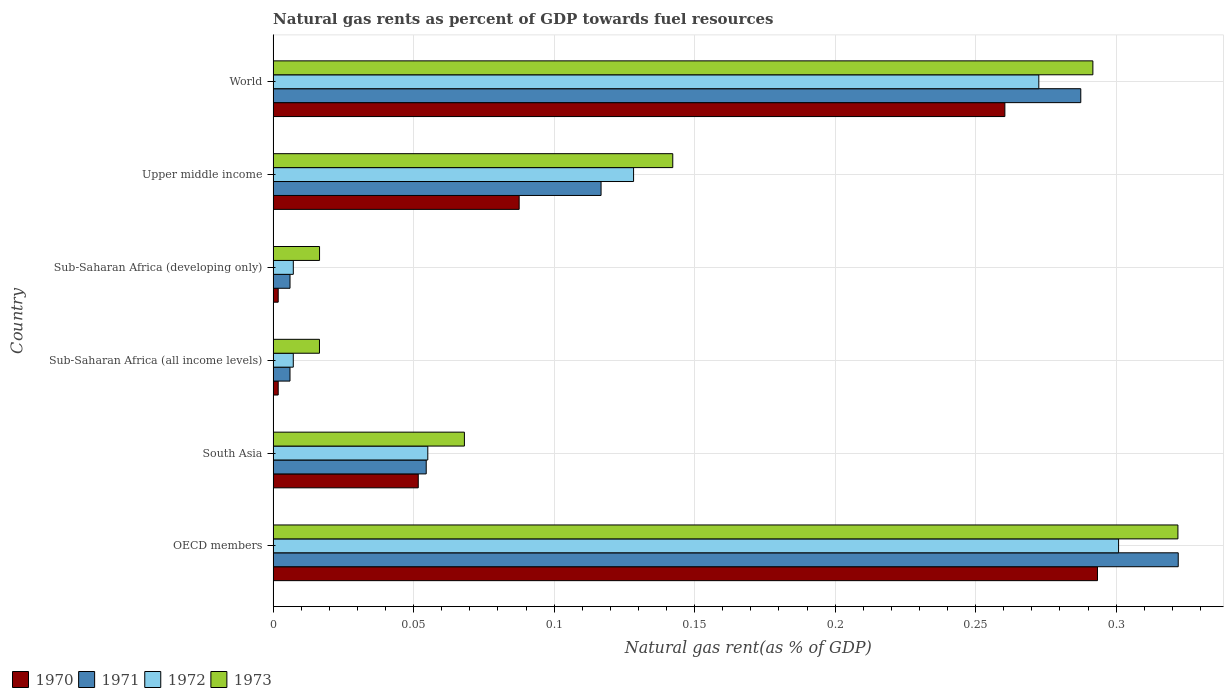Are the number of bars per tick equal to the number of legend labels?
Your answer should be very brief. Yes. How many bars are there on the 5th tick from the bottom?
Your response must be concise. 4. What is the label of the 2nd group of bars from the top?
Offer a very short reply. Upper middle income. In how many cases, is the number of bars for a given country not equal to the number of legend labels?
Your answer should be very brief. 0. What is the natural gas rent in 1970 in OECD members?
Provide a short and direct response. 0.29. Across all countries, what is the maximum natural gas rent in 1973?
Make the answer very short. 0.32. Across all countries, what is the minimum natural gas rent in 1971?
Ensure brevity in your answer.  0.01. In which country was the natural gas rent in 1972 minimum?
Your answer should be very brief. Sub-Saharan Africa (all income levels). What is the total natural gas rent in 1973 in the graph?
Offer a terse response. 0.86. What is the difference between the natural gas rent in 1972 in Upper middle income and that in World?
Provide a short and direct response. -0.14. What is the difference between the natural gas rent in 1972 in OECD members and the natural gas rent in 1973 in Upper middle income?
Keep it short and to the point. 0.16. What is the average natural gas rent in 1973 per country?
Provide a succinct answer. 0.14. What is the difference between the natural gas rent in 1970 and natural gas rent in 1973 in OECD members?
Your response must be concise. -0.03. In how many countries, is the natural gas rent in 1971 greater than 0.05 %?
Your response must be concise. 4. What is the ratio of the natural gas rent in 1971 in Sub-Saharan Africa (developing only) to that in World?
Make the answer very short. 0.02. What is the difference between the highest and the second highest natural gas rent in 1971?
Your answer should be very brief. 0.03. What is the difference between the highest and the lowest natural gas rent in 1970?
Your response must be concise. 0.29. In how many countries, is the natural gas rent in 1971 greater than the average natural gas rent in 1971 taken over all countries?
Offer a very short reply. 2. Is it the case that in every country, the sum of the natural gas rent in 1970 and natural gas rent in 1972 is greater than the sum of natural gas rent in 1971 and natural gas rent in 1973?
Provide a short and direct response. No. Is it the case that in every country, the sum of the natural gas rent in 1972 and natural gas rent in 1973 is greater than the natural gas rent in 1970?
Make the answer very short. Yes. How many countries are there in the graph?
Offer a terse response. 6. Does the graph contain grids?
Give a very brief answer. Yes. What is the title of the graph?
Your response must be concise. Natural gas rents as percent of GDP towards fuel resources. Does "1970" appear as one of the legend labels in the graph?
Offer a very short reply. Yes. What is the label or title of the X-axis?
Your answer should be compact. Natural gas rent(as % of GDP). What is the label or title of the Y-axis?
Keep it short and to the point. Country. What is the Natural gas rent(as % of GDP) of 1970 in OECD members?
Provide a short and direct response. 0.29. What is the Natural gas rent(as % of GDP) of 1971 in OECD members?
Make the answer very short. 0.32. What is the Natural gas rent(as % of GDP) of 1972 in OECD members?
Offer a very short reply. 0.3. What is the Natural gas rent(as % of GDP) of 1973 in OECD members?
Your response must be concise. 0.32. What is the Natural gas rent(as % of GDP) in 1970 in South Asia?
Make the answer very short. 0.05. What is the Natural gas rent(as % of GDP) of 1971 in South Asia?
Give a very brief answer. 0.05. What is the Natural gas rent(as % of GDP) of 1972 in South Asia?
Ensure brevity in your answer.  0.06. What is the Natural gas rent(as % of GDP) in 1973 in South Asia?
Your response must be concise. 0.07. What is the Natural gas rent(as % of GDP) of 1970 in Sub-Saharan Africa (all income levels)?
Offer a terse response. 0. What is the Natural gas rent(as % of GDP) of 1971 in Sub-Saharan Africa (all income levels)?
Your response must be concise. 0.01. What is the Natural gas rent(as % of GDP) of 1972 in Sub-Saharan Africa (all income levels)?
Offer a terse response. 0.01. What is the Natural gas rent(as % of GDP) in 1973 in Sub-Saharan Africa (all income levels)?
Provide a succinct answer. 0.02. What is the Natural gas rent(as % of GDP) of 1970 in Sub-Saharan Africa (developing only)?
Keep it short and to the point. 0. What is the Natural gas rent(as % of GDP) in 1971 in Sub-Saharan Africa (developing only)?
Make the answer very short. 0.01. What is the Natural gas rent(as % of GDP) in 1972 in Sub-Saharan Africa (developing only)?
Offer a terse response. 0.01. What is the Natural gas rent(as % of GDP) in 1973 in Sub-Saharan Africa (developing only)?
Keep it short and to the point. 0.02. What is the Natural gas rent(as % of GDP) in 1970 in Upper middle income?
Your answer should be compact. 0.09. What is the Natural gas rent(as % of GDP) in 1971 in Upper middle income?
Your response must be concise. 0.12. What is the Natural gas rent(as % of GDP) of 1972 in Upper middle income?
Offer a very short reply. 0.13. What is the Natural gas rent(as % of GDP) of 1973 in Upper middle income?
Provide a succinct answer. 0.14. What is the Natural gas rent(as % of GDP) of 1970 in World?
Provide a succinct answer. 0.26. What is the Natural gas rent(as % of GDP) in 1971 in World?
Your answer should be very brief. 0.29. What is the Natural gas rent(as % of GDP) of 1972 in World?
Make the answer very short. 0.27. What is the Natural gas rent(as % of GDP) of 1973 in World?
Make the answer very short. 0.29. Across all countries, what is the maximum Natural gas rent(as % of GDP) in 1970?
Keep it short and to the point. 0.29. Across all countries, what is the maximum Natural gas rent(as % of GDP) of 1971?
Make the answer very short. 0.32. Across all countries, what is the maximum Natural gas rent(as % of GDP) in 1972?
Ensure brevity in your answer.  0.3. Across all countries, what is the maximum Natural gas rent(as % of GDP) in 1973?
Provide a succinct answer. 0.32. Across all countries, what is the minimum Natural gas rent(as % of GDP) of 1970?
Provide a short and direct response. 0. Across all countries, what is the minimum Natural gas rent(as % of GDP) of 1971?
Make the answer very short. 0.01. Across all countries, what is the minimum Natural gas rent(as % of GDP) in 1972?
Give a very brief answer. 0.01. Across all countries, what is the minimum Natural gas rent(as % of GDP) of 1973?
Your response must be concise. 0.02. What is the total Natural gas rent(as % of GDP) of 1970 in the graph?
Give a very brief answer. 0.7. What is the total Natural gas rent(as % of GDP) in 1971 in the graph?
Offer a very short reply. 0.79. What is the total Natural gas rent(as % of GDP) in 1972 in the graph?
Your answer should be very brief. 0.77. What is the total Natural gas rent(as % of GDP) in 1973 in the graph?
Offer a very short reply. 0.86. What is the difference between the Natural gas rent(as % of GDP) of 1970 in OECD members and that in South Asia?
Offer a terse response. 0.24. What is the difference between the Natural gas rent(as % of GDP) in 1971 in OECD members and that in South Asia?
Offer a terse response. 0.27. What is the difference between the Natural gas rent(as % of GDP) of 1972 in OECD members and that in South Asia?
Keep it short and to the point. 0.25. What is the difference between the Natural gas rent(as % of GDP) in 1973 in OECD members and that in South Asia?
Ensure brevity in your answer.  0.25. What is the difference between the Natural gas rent(as % of GDP) in 1970 in OECD members and that in Sub-Saharan Africa (all income levels)?
Keep it short and to the point. 0.29. What is the difference between the Natural gas rent(as % of GDP) in 1971 in OECD members and that in Sub-Saharan Africa (all income levels)?
Give a very brief answer. 0.32. What is the difference between the Natural gas rent(as % of GDP) in 1972 in OECD members and that in Sub-Saharan Africa (all income levels)?
Provide a short and direct response. 0.29. What is the difference between the Natural gas rent(as % of GDP) in 1973 in OECD members and that in Sub-Saharan Africa (all income levels)?
Give a very brief answer. 0.31. What is the difference between the Natural gas rent(as % of GDP) of 1970 in OECD members and that in Sub-Saharan Africa (developing only)?
Give a very brief answer. 0.29. What is the difference between the Natural gas rent(as % of GDP) in 1971 in OECD members and that in Sub-Saharan Africa (developing only)?
Your answer should be compact. 0.32. What is the difference between the Natural gas rent(as % of GDP) of 1972 in OECD members and that in Sub-Saharan Africa (developing only)?
Your response must be concise. 0.29. What is the difference between the Natural gas rent(as % of GDP) of 1973 in OECD members and that in Sub-Saharan Africa (developing only)?
Ensure brevity in your answer.  0.31. What is the difference between the Natural gas rent(as % of GDP) in 1970 in OECD members and that in Upper middle income?
Offer a very short reply. 0.21. What is the difference between the Natural gas rent(as % of GDP) of 1971 in OECD members and that in Upper middle income?
Give a very brief answer. 0.21. What is the difference between the Natural gas rent(as % of GDP) of 1972 in OECD members and that in Upper middle income?
Offer a terse response. 0.17. What is the difference between the Natural gas rent(as % of GDP) in 1973 in OECD members and that in Upper middle income?
Ensure brevity in your answer.  0.18. What is the difference between the Natural gas rent(as % of GDP) in 1970 in OECD members and that in World?
Keep it short and to the point. 0.03. What is the difference between the Natural gas rent(as % of GDP) of 1971 in OECD members and that in World?
Ensure brevity in your answer.  0.03. What is the difference between the Natural gas rent(as % of GDP) in 1972 in OECD members and that in World?
Offer a very short reply. 0.03. What is the difference between the Natural gas rent(as % of GDP) of 1973 in OECD members and that in World?
Provide a succinct answer. 0.03. What is the difference between the Natural gas rent(as % of GDP) of 1970 in South Asia and that in Sub-Saharan Africa (all income levels)?
Provide a succinct answer. 0.05. What is the difference between the Natural gas rent(as % of GDP) of 1971 in South Asia and that in Sub-Saharan Africa (all income levels)?
Your response must be concise. 0.05. What is the difference between the Natural gas rent(as % of GDP) of 1972 in South Asia and that in Sub-Saharan Africa (all income levels)?
Offer a terse response. 0.05. What is the difference between the Natural gas rent(as % of GDP) in 1973 in South Asia and that in Sub-Saharan Africa (all income levels)?
Give a very brief answer. 0.05. What is the difference between the Natural gas rent(as % of GDP) in 1970 in South Asia and that in Sub-Saharan Africa (developing only)?
Your answer should be very brief. 0.05. What is the difference between the Natural gas rent(as % of GDP) of 1971 in South Asia and that in Sub-Saharan Africa (developing only)?
Keep it short and to the point. 0.05. What is the difference between the Natural gas rent(as % of GDP) of 1972 in South Asia and that in Sub-Saharan Africa (developing only)?
Offer a terse response. 0.05. What is the difference between the Natural gas rent(as % of GDP) in 1973 in South Asia and that in Sub-Saharan Africa (developing only)?
Keep it short and to the point. 0.05. What is the difference between the Natural gas rent(as % of GDP) of 1970 in South Asia and that in Upper middle income?
Keep it short and to the point. -0.04. What is the difference between the Natural gas rent(as % of GDP) of 1971 in South Asia and that in Upper middle income?
Keep it short and to the point. -0.06. What is the difference between the Natural gas rent(as % of GDP) in 1972 in South Asia and that in Upper middle income?
Provide a short and direct response. -0.07. What is the difference between the Natural gas rent(as % of GDP) of 1973 in South Asia and that in Upper middle income?
Give a very brief answer. -0.07. What is the difference between the Natural gas rent(as % of GDP) in 1970 in South Asia and that in World?
Provide a succinct answer. -0.21. What is the difference between the Natural gas rent(as % of GDP) in 1971 in South Asia and that in World?
Offer a terse response. -0.23. What is the difference between the Natural gas rent(as % of GDP) in 1972 in South Asia and that in World?
Your response must be concise. -0.22. What is the difference between the Natural gas rent(as % of GDP) of 1973 in South Asia and that in World?
Offer a terse response. -0.22. What is the difference between the Natural gas rent(as % of GDP) in 1970 in Sub-Saharan Africa (all income levels) and that in Sub-Saharan Africa (developing only)?
Your response must be concise. -0. What is the difference between the Natural gas rent(as % of GDP) in 1971 in Sub-Saharan Africa (all income levels) and that in Sub-Saharan Africa (developing only)?
Your response must be concise. -0. What is the difference between the Natural gas rent(as % of GDP) in 1972 in Sub-Saharan Africa (all income levels) and that in Sub-Saharan Africa (developing only)?
Provide a short and direct response. -0. What is the difference between the Natural gas rent(as % of GDP) of 1973 in Sub-Saharan Africa (all income levels) and that in Sub-Saharan Africa (developing only)?
Provide a succinct answer. -0. What is the difference between the Natural gas rent(as % of GDP) in 1970 in Sub-Saharan Africa (all income levels) and that in Upper middle income?
Your response must be concise. -0.09. What is the difference between the Natural gas rent(as % of GDP) in 1971 in Sub-Saharan Africa (all income levels) and that in Upper middle income?
Give a very brief answer. -0.11. What is the difference between the Natural gas rent(as % of GDP) in 1972 in Sub-Saharan Africa (all income levels) and that in Upper middle income?
Provide a succinct answer. -0.12. What is the difference between the Natural gas rent(as % of GDP) of 1973 in Sub-Saharan Africa (all income levels) and that in Upper middle income?
Offer a terse response. -0.13. What is the difference between the Natural gas rent(as % of GDP) in 1970 in Sub-Saharan Africa (all income levels) and that in World?
Your response must be concise. -0.26. What is the difference between the Natural gas rent(as % of GDP) of 1971 in Sub-Saharan Africa (all income levels) and that in World?
Offer a terse response. -0.28. What is the difference between the Natural gas rent(as % of GDP) of 1972 in Sub-Saharan Africa (all income levels) and that in World?
Offer a terse response. -0.27. What is the difference between the Natural gas rent(as % of GDP) in 1973 in Sub-Saharan Africa (all income levels) and that in World?
Give a very brief answer. -0.28. What is the difference between the Natural gas rent(as % of GDP) of 1970 in Sub-Saharan Africa (developing only) and that in Upper middle income?
Make the answer very short. -0.09. What is the difference between the Natural gas rent(as % of GDP) in 1971 in Sub-Saharan Africa (developing only) and that in Upper middle income?
Keep it short and to the point. -0.11. What is the difference between the Natural gas rent(as % of GDP) in 1972 in Sub-Saharan Africa (developing only) and that in Upper middle income?
Ensure brevity in your answer.  -0.12. What is the difference between the Natural gas rent(as % of GDP) in 1973 in Sub-Saharan Africa (developing only) and that in Upper middle income?
Ensure brevity in your answer.  -0.13. What is the difference between the Natural gas rent(as % of GDP) of 1970 in Sub-Saharan Africa (developing only) and that in World?
Keep it short and to the point. -0.26. What is the difference between the Natural gas rent(as % of GDP) of 1971 in Sub-Saharan Africa (developing only) and that in World?
Offer a terse response. -0.28. What is the difference between the Natural gas rent(as % of GDP) in 1972 in Sub-Saharan Africa (developing only) and that in World?
Your answer should be compact. -0.27. What is the difference between the Natural gas rent(as % of GDP) in 1973 in Sub-Saharan Africa (developing only) and that in World?
Make the answer very short. -0.28. What is the difference between the Natural gas rent(as % of GDP) in 1970 in Upper middle income and that in World?
Keep it short and to the point. -0.17. What is the difference between the Natural gas rent(as % of GDP) in 1971 in Upper middle income and that in World?
Offer a terse response. -0.17. What is the difference between the Natural gas rent(as % of GDP) in 1972 in Upper middle income and that in World?
Give a very brief answer. -0.14. What is the difference between the Natural gas rent(as % of GDP) in 1973 in Upper middle income and that in World?
Offer a very short reply. -0.15. What is the difference between the Natural gas rent(as % of GDP) in 1970 in OECD members and the Natural gas rent(as % of GDP) in 1971 in South Asia?
Ensure brevity in your answer.  0.24. What is the difference between the Natural gas rent(as % of GDP) in 1970 in OECD members and the Natural gas rent(as % of GDP) in 1972 in South Asia?
Give a very brief answer. 0.24. What is the difference between the Natural gas rent(as % of GDP) in 1970 in OECD members and the Natural gas rent(as % of GDP) in 1973 in South Asia?
Make the answer very short. 0.23. What is the difference between the Natural gas rent(as % of GDP) in 1971 in OECD members and the Natural gas rent(as % of GDP) in 1972 in South Asia?
Provide a succinct answer. 0.27. What is the difference between the Natural gas rent(as % of GDP) in 1971 in OECD members and the Natural gas rent(as % of GDP) in 1973 in South Asia?
Provide a short and direct response. 0.25. What is the difference between the Natural gas rent(as % of GDP) in 1972 in OECD members and the Natural gas rent(as % of GDP) in 1973 in South Asia?
Provide a short and direct response. 0.23. What is the difference between the Natural gas rent(as % of GDP) in 1970 in OECD members and the Natural gas rent(as % of GDP) in 1971 in Sub-Saharan Africa (all income levels)?
Provide a short and direct response. 0.29. What is the difference between the Natural gas rent(as % of GDP) of 1970 in OECD members and the Natural gas rent(as % of GDP) of 1972 in Sub-Saharan Africa (all income levels)?
Your answer should be very brief. 0.29. What is the difference between the Natural gas rent(as % of GDP) of 1970 in OECD members and the Natural gas rent(as % of GDP) of 1973 in Sub-Saharan Africa (all income levels)?
Your response must be concise. 0.28. What is the difference between the Natural gas rent(as % of GDP) in 1971 in OECD members and the Natural gas rent(as % of GDP) in 1972 in Sub-Saharan Africa (all income levels)?
Your answer should be compact. 0.31. What is the difference between the Natural gas rent(as % of GDP) in 1971 in OECD members and the Natural gas rent(as % of GDP) in 1973 in Sub-Saharan Africa (all income levels)?
Give a very brief answer. 0.31. What is the difference between the Natural gas rent(as % of GDP) in 1972 in OECD members and the Natural gas rent(as % of GDP) in 1973 in Sub-Saharan Africa (all income levels)?
Your answer should be very brief. 0.28. What is the difference between the Natural gas rent(as % of GDP) in 1970 in OECD members and the Natural gas rent(as % of GDP) in 1971 in Sub-Saharan Africa (developing only)?
Offer a terse response. 0.29. What is the difference between the Natural gas rent(as % of GDP) of 1970 in OECD members and the Natural gas rent(as % of GDP) of 1972 in Sub-Saharan Africa (developing only)?
Offer a very short reply. 0.29. What is the difference between the Natural gas rent(as % of GDP) in 1970 in OECD members and the Natural gas rent(as % of GDP) in 1973 in Sub-Saharan Africa (developing only)?
Make the answer very short. 0.28. What is the difference between the Natural gas rent(as % of GDP) in 1971 in OECD members and the Natural gas rent(as % of GDP) in 1972 in Sub-Saharan Africa (developing only)?
Provide a short and direct response. 0.31. What is the difference between the Natural gas rent(as % of GDP) of 1971 in OECD members and the Natural gas rent(as % of GDP) of 1973 in Sub-Saharan Africa (developing only)?
Give a very brief answer. 0.31. What is the difference between the Natural gas rent(as % of GDP) of 1972 in OECD members and the Natural gas rent(as % of GDP) of 1973 in Sub-Saharan Africa (developing only)?
Offer a terse response. 0.28. What is the difference between the Natural gas rent(as % of GDP) of 1970 in OECD members and the Natural gas rent(as % of GDP) of 1971 in Upper middle income?
Your response must be concise. 0.18. What is the difference between the Natural gas rent(as % of GDP) in 1970 in OECD members and the Natural gas rent(as % of GDP) in 1972 in Upper middle income?
Offer a terse response. 0.17. What is the difference between the Natural gas rent(as % of GDP) of 1970 in OECD members and the Natural gas rent(as % of GDP) of 1973 in Upper middle income?
Keep it short and to the point. 0.15. What is the difference between the Natural gas rent(as % of GDP) of 1971 in OECD members and the Natural gas rent(as % of GDP) of 1972 in Upper middle income?
Keep it short and to the point. 0.19. What is the difference between the Natural gas rent(as % of GDP) of 1971 in OECD members and the Natural gas rent(as % of GDP) of 1973 in Upper middle income?
Your response must be concise. 0.18. What is the difference between the Natural gas rent(as % of GDP) in 1972 in OECD members and the Natural gas rent(as % of GDP) in 1973 in Upper middle income?
Offer a very short reply. 0.16. What is the difference between the Natural gas rent(as % of GDP) in 1970 in OECD members and the Natural gas rent(as % of GDP) in 1971 in World?
Provide a short and direct response. 0.01. What is the difference between the Natural gas rent(as % of GDP) of 1970 in OECD members and the Natural gas rent(as % of GDP) of 1972 in World?
Give a very brief answer. 0.02. What is the difference between the Natural gas rent(as % of GDP) of 1970 in OECD members and the Natural gas rent(as % of GDP) of 1973 in World?
Keep it short and to the point. 0. What is the difference between the Natural gas rent(as % of GDP) in 1971 in OECD members and the Natural gas rent(as % of GDP) in 1972 in World?
Make the answer very short. 0.05. What is the difference between the Natural gas rent(as % of GDP) of 1971 in OECD members and the Natural gas rent(as % of GDP) of 1973 in World?
Provide a succinct answer. 0.03. What is the difference between the Natural gas rent(as % of GDP) in 1972 in OECD members and the Natural gas rent(as % of GDP) in 1973 in World?
Offer a terse response. 0.01. What is the difference between the Natural gas rent(as % of GDP) of 1970 in South Asia and the Natural gas rent(as % of GDP) of 1971 in Sub-Saharan Africa (all income levels)?
Your response must be concise. 0.05. What is the difference between the Natural gas rent(as % of GDP) in 1970 in South Asia and the Natural gas rent(as % of GDP) in 1972 in Sub-Saharan Africa (all income levels)?
Your response must be concise. 0.04. What is the difference between the Natural gas rent(as % of GDP) of 1970 in South Asia and the Natural gas rent(as % of GDP) of 1973 in Sub-Saharan Africa (all income levels)?
Offer a terse response. 0.04. What is the difference between the Natural gas rent(as % of GDP) of 1971 in South Asia and the Natural gas rent(as % of GDP) of 1972 in Sub-Saharan Africa (all income levels)?
Your answer should be compact. 0.05. What is the difference between the Natural gas rent(as % of GDP) of 1971 in South Asia and the Natural gas rent(as % of GDP) of 1973 in Sub-Saharan Africa (all income levels)?
Provide a succinct answer. 0.04. What is the difference between the Natural gas rent(as % of GDP) in 1972 in South Asia and the Natural gas rent(as % of GDP) in 1973 in Sub-Saharan Africa (all income levels)?
Offer a very short reply. 0.04. What is the difference between the Natural gas rent(as % of GDP) of 1970 in South Asia and the Natural gas rent(as % of GDP) of 1971 in Sub-Saharan Africa (developing only)?
Your answer should be compact. 0.05. What is the difference between the Natural gas rent(as % of GDP) in 1970 in South Asia and the Natural gas rent(as % of GDP) in 1972 in Sub-Saharan Africa (developing only)?
Give a very brief answer. 0.04. What is the difference between the Natural gas rent(as % of GDP) in 1970 in South Asia and the Natural gas rent(as % of GDP) in 1973 in Sub-Saharan Africa (developing only)?
Make the answer very short. 0.04. What is the difference between the Natural gas rent(as % of GDP) in 1971 in South Asia and the Natural gas rent(as % of GDP) in 1972 in Sub-Saharan Africa (developing only)?
Provide a succinct answer. 0.05. What is the difference between the Natural gas rent(as % of GDP) in 1971 in South Asia and the Natural gas rent(as % of GDP) in 1973 in Sub-Saharan Africa (developing only)?
Offer a terse response. 0.04. What is the difference between the Natural gas rent(as % of GDP) in 1972 in South Asia and the Natural gas rent(as % of GDP) in 1973 in Sub-Saharan Africa (developing only)?
Provide a succinct answer. 0.04. What is the difference between the Natural gas rent(as % of GDP) in 1970 in South Asia and the Natural gas rent(as % of GDP) in 1971 in Upper middle income?
Offer a terse response. -0.07. What is the difference between the Natural gas rent(as % of GDP) of 1970 in South Asia and the Natural gas rent(as % of GDP) of 1972 in Upper middle income?
Your answer should be very brief. -0.08. What is the difference between the Natural gas rent(as % of GDP) of 1970 in South Asia and the Natural gas rent(as % of GDP) of 1973 in Upper middle income?
Make the answer very short. -0.09. What is the difference between the Natural gas rent(as % of GDP) in 1971 in South Asia and the Natural gas rent(as % of GDP) in 1972 in Upper middle income?
Ensure brevity in your answer.  -0.07. What is the difference between the Natural gas rent(as % of GDP) in 1971 in South Asia and the Natural gas rent(as % of GDP) in 1973 in Upper middle income?
Offer a terse response. -0.09. What is the difference between the Natural gas rent(as % of GDP) in 1972 in South Asia and the Natural gas rent(as % of GDP) in 1973 in Upper middle income?
Provide a succinct answer. -0.09. What is the difference between the Natural gas rent(as % of GDP) in 1970 in South Asia and the Natural gas rent(as % of GDP) in 1971 in World?
Your answer should be compact. -0.24. What is the difference between the Natural gas rent(as % of GDP) of 1970 in South Asia and the Natural gas rent(as % of GDP) of 1972 in World?
Provide a succinct answer. -0.22. What is the difference between the Natural gas rent(as % of GDP) of 1970 in South Asia and the Natural gas rent(as % of GDP) of 1973 in World?
Offer a terse response. -0.24. What is the difference between the Natural gas rent(as % of GDP) of 1971 in South Asia and the Natural gas rent(as % of GDP) of 1972 in World?
Offer a very short reply. -0.22. What is the difference between the Natural gas rent(as % of GDP) of 1971 in South Asia and the Natural gas rent(as % of GDP) of 1973 in World?
Ensure brevity in your answer.  -0.24. What is the difference between the Natural gas rent(as % of GDP) of 1972 in South Asia and the Natural gas rent(as % of GDP) of 1973 in World?
Your answer should be compact. -0.24. What is the difference between the Natural gas rent(as % of GDP) in 1970 in Sub-Saharan Africa (all income levels) and the Natural gas rent(as % of GDP) in 1971 in Sub-Saharan Africa (developing only)?
Ensure brevity in your answer.  -0. What is the difference between the Natural gas rent(as % of GDP) of 1970 in Sub-Saharan Africa (all income levels) and the Natural gas rent(as % of GDP) of 1972 in Sub-Saharan Africa (developing only)?
Your answer should be very brief. -0.01. What is the difference between the Natural gas rent(as % of GDP) in 1970 in Sub-Saharan Africa (all income levels) and the Natural gas rent(as % of GDP) in 1973 in Sub-Saharan Africa (developing only)?
Your answer should be very brief. -0.01. What is the difference between the Natural gas rent(as % of GDP) in 1971 in Sub-Saharan Africa (all income levels) and the Natural gas rent(as % of GDP) in 1972 in Sub-Saharan Africa (developing only)?
Ensure brevity in your answer.  -0. What is the difference between the Natural gas rent(as % of GDP) in 1971 in Sub-Saharan Africa (all income levels) and the Natural gas rent(as % of GDP) in 1973 in Sub-Saharan Africa (developing only)?
Offer a terse response. -0.01. What is the difference between the Natural gas rent(as % of GDP) in 1972 in Sub-Saharan Africa (all income levels) and the Natural gas rent(as % of GDP) in 1973 in Sub-Saharan Africa (developing only)?
Your answer should be very brief. -0.01. What is the difference between the Natural gas rent(as % of GDP) of 1970 in Sub-Saharan Africa (all income levels) and the Natural gas rent(as % of GDP) of 1971 in Upper middle income?
Give a very brief answer. -0.11. What is the difference between the Natural gas rent(as % of GDP) in 1970 in Sub-Saharan Africa (all income levels) and the Natural gas rent(as % of GDP) in 1972 in Upper middle income?
Offer a very short reply. -0.13. What is the difference between the Natural gas rent(as % of GDP) in 1970 in Sub-Saharan Africa (all income levels) and the Natural gas rent(as % of GDP) in 1973 in Upper middle income?
Your answer should be very brief. -0.14. What is the difference between the Natural gas rent(as % of GDP) in 1971 in Sub-Saharan Africa (all income levels) and the Natural gas rent(as % of GDP) in 1972 in Upper middle income?
Ensure brevity in your answer.  -0.12. What is the difference between the Natural gas rent(as % of GDP) in 1971 in Sub-Saharan Africa (all income levels) and the Natural gas rent(as % of GDP) in 1973 in Upper middle income?
Ensure brevity in your answer.  -0.14. What is the difference between the Natural gas rent(as % of GDP) in 1972 in Sub-Saharan Africa (all income levels) and the Natural gas rent(as % of GDP) in 1973 in Upper middle income?
Your answer should be very brief. -0.14. What is the difference between the Natural gas rent(as % of GDP) in 1970 in Sub-Saharan Africa (all income levels) and the Natural gas rent(as % of GDP) in 1971 in World?
Give a very brief answer. -0.29. What is the difference between the Natural gas rent(as % of GDP) in 1970 in Sub-Saharan Africa (all income levels) and the Natural gas rent(as % of GDP) in 1972 in World?
Give a very brief answer. -0.27. What is the difference between the Natural gas rent(as % of GDP) in 1970 in Sub-Saharan Africa (all income levels) and the Natural gas rent(as % of GDP) in 1973 in World?
Provide a succinct answer. -0.29. What is the difference between the Natural gas rent(as % of GDP) in 1971 in Sub-Saharan Africa (all income levels) and the Natural gas rent(as % of GDP) in 1972 in World?
Keep it short and to the point. -0.27. What is the difference between the Natural gas rent(as % of GDP) of 1971 in Sub-Saharan Africa (all income levels) and the Natural gas rent(as % of GDP) of 1973 in World?
Give a very brief answer. -0.29. What is the difference between the Natural gas rent(as % of GDP) of 1972 in Sub-Saharan Africa (all income levels) and the Natural gas rent(as % of GDP) of 1973 in World?
Offer a very short reply. -0.28. What is the difference between the Natural gas rent(as % of GDP) of 1970 in Sub-Saharan Africa (developing only) and the Natural gas rent(as % of GDP) of 1971 in Upper middle income?
Your answer should be compact. -0.11. What is the difference between the Natural gas rent(as % of GDP) of 1970 in Sub-Saharan Africa (developing only) and the Natural gas rent(as % of GDP) of 1972 in Upper middle income?
Give a very brief answer. -0.13. What is the difference between the Natural gas rent(as % of GDP) of 1970 in Sub-Saharan Africa (developing only) and the Natural gas rent(as % of GDP) of 1973 in Upper middle income?
Ensure brevity in your answer.  -0.14. What is the difference between the Natural gas rent(as % of GDP) in 1971 in Sub-Saharan Africa (developing only) and the Natural gas rent(as % of GDP) in 1972 in Upper middle income?
Offer a terse response. -0.12. What is the difference between the Natural gas rent(as % of GDP) of 1971 in Sub-Saharan Africa (developing only) and the Natural gas rent(as % of GDP) of 1973 in Upper middle income?
Offer a very short reply. -0.14. What is the difference between the Natural gas rent(as % of GDP) in 1972 in Sub-Saharan Africa (developing only) and the Natural gas rent(as % of GDP) in 1973 in Upper middle income?
Offer a very short reply. -0.14. What is the difference between the Natural gas rent(as % of GDP) in 1970 in Sub-Saharan Africa (developing only) and the Natural gas rent(as % of GDP) in 1971 in World?
Your answer should be very brief. -0.29. What is the difference between the Natural gas rent(as % of GDP) in 1970 in Sub-Saharan Africa (developing only) and the Natural gas rent(as % of GDP) in 1972 in World?
Offer a terse response. -0.27. What is the difference between the Natural gas rent(as % of GDP) of 1970 in Sub-Saharan Africa (developing only) and the Natural gas rent(as % of GDP) of 1973 in World?
Offer a terse response. -0.29. What is the difference between the Natural gas rent(as % of GDP) in 1971 in Sub-Saharan Africa (developing only) and the Natural gas rent(as % of GDP) in 1972 in World?
Your response must be concise. -0.27. What is the difference between the Natural gas rent(as % of GDP) of 1971 in Sub-Saharan Africa (developing only) and the Natural gas rent(as % of GDP) of 1973 in World?
Ensure brevity in your answer.  -0.29. What is the difference between the Natural gas rent(as % of GDP) in 1972 in Sub-Saharan Africa (developing only) and the Natural gas rent(as % of GDP) in 1973 in World?
Offer a terse response. -0.28. What is the difference between the Natural gas rent(as % of GDP) of 1970 in Upper middle income and the Natural gas rent(as % of GDP) of 1971 in World?
Provide a short and direct response. -0.2. What is the difference between the Natural gas rent(as % of GDP) of 1970 in Upper middle income and the Natural gas rent(as % of GDP) of 1972 in World?
Your response must be concise. -0.18. What is the difference between the Natural gas rent(as % of GDP) of 1970 in Upper middle income and the Natural gas rent(as % of GDP) of 1973 in World?
Offer a very short reply. -0.2. What is the difference between the Natural gas rent(as % of GDP) of 1971 in Upper middle income and the Natural gas rent(as % of GDP) of 1972 in World?
Give a very brief answer. -0.16. What is the difference between the Natural gas rent(as % of GDP) in 1971 in Upper middle income and the Natural gas rent(as % of GDP) in 1973 in World?
Provide a short and direct response. -0.17. What is the difference between the Natural gas rent(as % of GDP) of 1972 in Upper middle income and the Natural gas rent(as % of GDP) of 1973 in World?
Ensure brevity in your answer.  -0.16. What is the average Natural gas rent(as % of GDP) of 1970 per country?
Keep it short and to the point. 0.12. What is the average Natural gas rent(as % of GDP) in 1971 per country?
Provide a short and direct response. 0.13. What is the average Natural gas rent(as % of GDP) of 1972 per country?
Your response must be concise. 0.13. What is the average Natural gas rent(as % of GDP) of 1973 per country?
Ensure brevity in your answer.  0.14. What is the difference between the Natural gas rent(as % of GDP) in 1970 and Natural gas rent(as % of GDP) in 1971 in OECD members?
Provide a short and direct response. -0.03. What is the difference between the Natural gas rent(as % of GDP) of 1970 and Natural gas rent(as % of GDP) of 1972 in OECD members?
Your response must be concise. -0.01. What is the difference between the Natural gas rent(as % of GDP) in 1970 and Natural gas rent(as % of GDP) in 1973 in OECD members?
Provide a succinct answer. -0.03. What is the difference between the Natural gas rent(as % of GDP) of 1971 and Natural gas rent(as % of GDP) of 1972 in OECD members?
Your response must be concise. 0.02. What is the difference between the Natural gas rent(as % of GDP) in 1972 and Natural gas rent(as % of GDP) in 1973 in OECD members?
Offer a terse response. -0.02. What is the difference between the Natural gas rent(as % of GDP) in 1970 and Natural gas rent(as % of GDP) in 1971 in South Asia?
Your response must be concise. -0. What is the difference between the Natural gas rent(as % of GDP) of 1970 and Natural gas rent(as % of GDP) of 1972 in South Asia?
Give a very brief answer. -0. What is the difference between the Natural gas rent(as % of GDP) in 1970 and Natural gas rent(as % of GDP) in 1973 in South Asia?
Your answer should be very brief. -0.02. What is the difference between the Natural gas rent(as % of GDP) of 1971 and Natural gas rent(as % of GDP) of 1972 in South Asia?
Ensure brevity in your answer.  -0. What is the difference between the Natural gas rent(as % of GDP) of 1971 and Natural gas rent(as % of GDP) of 1973 in South Asia?
Provide a short and direct response. -0.01. What is the difference between the Natural gas rent(as % of GDP) in 1972 and Natural gas rent(as % of GDP) in 1973 in South Asia?
Ensure brevity in your answer.  -0.01. What is the difference between the Natural gas rent(as % of GDP) of 1970 and Natural gas rent(as % of GDP) of 1971 in Sub-Saharan Africa (all income levels)?
Ensure brevity in your answer.  -0. What is the difference between the Natural gas rent(as % of GDP) in 1970 and Natural gas rent(as % of GDP) in 1972 in Sub-Saharan Africa (all income levels)?
Make the answer very short. -0.01. What is the difference between the Natural gas rent(as % of GDP) in 1970 and Natural gas rent(as % of GDP) in 1973 in Sub-Saharan Africa (all income levels)?
Provide a succinct answer. -0.01. What is the difference between the Natural gas rent(as % of GDP) of 1971 and Natural gas rent(as % of GDP) of 1972 in Sub-Saharan Africa (all income levels)?
Offer a very short reply. -0. What is the difference between the Natural gas rent(as % of GDP) in 1971 and Natural gas rent(as % of GDP) in 1973 in Sub-Saharan Africa (all income levels)?
Provide a short and direct response. -0.01. What is the difference between the Natural gas rent(as % of GDP) of 1972 and Natural gas rent(as % of GDP) of 1973 in Sub-Saharan Africa (all income levels)?
Ensure brevity in your answer.  -0.01. What is the difference between the Natural gas rent(as % of GDP) of 1970 and Natural gas rent(as % of GDP) of 1971 in Sub-Saharan Africa (developing only)?
Offer a terse response. -0. What is the difference between the Natural gas rent(as % of GDP) in 1970 and Natural gas rent(as % of GDP) in 1972 in Sub-Saharan Africa (developing only)?
Your response must be concise. -0.01. What is the difference between the Natural gas rent(as % of GDP) of 1970 and Natural gas rent(as % of GDP) of 1973 in Sub-Saharan Africa (developing only)?
Keep it short and to the point. -0.01. What is the difference between the Natural gas rent(as % of GDP) in 1971 and Natural gas rent(as % of GDP) in 1972 in Sub-Saharan Africa (developing only)?
Offer a terse response. -0. What is the difference between the Natural gas rent(as % of GDP) of 1971 and Natural gas rent(as % of GDP) of 1973 in Sub-Saharan Africa (developing only)?
Offer a terse response. -0.01. What is the difference between the Natural gas rent(as % of GDP) of 1972 and Natural gas rent(as % of GDP) of 1973 in Sub-Saharan Africa (developing only)?
Give a very brief answer. -0.01. What is the difference between the Natural gas rent(as % of GDP) in 1970 and Natural gas rent(as % of GDP) in 1971 in Upper middle income?
Your response must be concise. -0.03. What is the difference between the Natural gas rent(as % of GDP) in 1970 and Natural gas rent(as % of GDP) in 1972 in Upper middle income?
Give a very brief answer. -0.04. What is the difference between the Natural gas rent(as % of GDP) in 1970 and Natural gas rent(as % of GDP) in 1973 in Upper middle income?
Make the answer very short. -0.05. What is the difference between the Natural gas rent(as % of GDP) of 1971 and Natural gas rent(as % of GDP) of 1972 in Upper middle income?
Offer a very short reply. -0.01. What is the difference between the Natural gas rent(as % of GDP) in 1971 and Natural gas rent(as % of GDP) in 1973 in Upper middle income?
Your answer should be compact. -0.03. What is the difference between the Natural gas rent(as % of GDP) of 1972 and Natural gas rent(as % of GDP) of 1973 in Upper middle income?
Provide a short and direct response. -0.01. What is the difference between the Natural gas rent(as % of GDP) in 1970 and Natural gas rent(as % of GDP) in 1971 in World?
Offer a very short reply. -0.03. What is the difference between the Natural gas rent(as % of GDP) of 1970 and Natural gas rent(as % of GDP) of 1972 in World?
Your response must be concise. -0.01. What is the difference between the Natural gas rent(as % of GDP) in 1970 and Natural gas rent(as % of GDP) in 1973 in World?
Your answer should be very brief. -0.03. What is the difference between the Natural gas rent(as % of GDP) of 1971 and Natural gas rent(as % of GDP) of 1972 in World?
Keep it short and to the point. 0.01. What is the difference between the Natural gas rent(as % of GDP) in 1971 and Natural gas rent(as % of GDP) in 1973 in World?
Keep it short and to the point. -0. What is the difference between the Natural gas rent(as % of GDP) of 1972 and Natural gas rent(as % of GDP) of 1973 in World?
Your answer should be compact. -0.02. What is the ratio of the Natural gas rent(as % of GDP) of 1970 in OECD members to that in South Asia?
Provide a short and direct response. 5.68. What is the ratio of the Natural gas rent(as % of GDP) of 1971 in OECD members to that in South Asia?
Offer a very short reply. 5.91. What is the ratio of the Natural gas rent(as % of GDP) of 1972 in OECD members to that in South Asia?
Your response must be concise. 5.47. What is the ratio of the Natural gas rent(as % of GDP) of 1973 in OECD members to that in South Asia?
Your answer should be very brief. 4.73. What is the ratio of the Natural gas rent(as % of GDP) in 1970 in OECD members to that in Sub-Saharan Africa (all income levels)?
Your answer should be very brief. 162.3. What is the ratio of the Natural gas rent(as % of GDP) of 1971 in OECD members to that in Sub-Saharan Africa (all income levels)?
Provide a short and direct response. 53.64. What is the ratio of the Natural gas rent(as % of GDP) in 1972 in OECD members to that in Sub-Saharan Africa (all income levels)?
Provide a short and direct response. 41.95. What is the ratio of the Natural gas rent(as % of GDP) in 1973 in OECD members to that in Sub-Saharan Africa (all income levels)?
Give a very brief answer. 19.52. What is the ratio of the Natural gas rent(as % of GDP) in 1970 in OECD members to that in Sub-Saharan Africa (developing only)?
Offer a terse response. 162.05. What is the ratio of the Natural gas rent(as % of GDP) of 1971 in OECD members to that in Sub-Saharan Africa (developing only)?
Ensure brevity in your answer.  53.56. What is the ratio of the Natural gas rent(as % of GDP) of 1972 in OECD members to that in Sub-Saharan Africa (developing only)?
Your response must be concise. 41.89. What is the ratio of the Natural gas rent(as % of GDP) in 1973 in OECD members to that in Sub-Saharan Africa (developing only)?
Offer a terse response. 19.49. What is the ratio of the Natural gas rent(as % of GDP) in 1970 in OECD members to that in Upper middle income?
Your answer should be very brief. 3.35. What is the ratio of the Natural gas rent(as % of GDP) in 1971 in OECD members to that in Upper middle income?
Give a very brief answer. 2.76. What is the ratio of the Natural gas rent(as % of GDP) in 1972 in OECD members to that in Upper middle income?
Offer a very short reply. 2.35. What is the ratio of the Natural gas rent(as % of GDP) in 1973 in OECD members to that in Upper middle income?
Provide a succinct answer. 2.26. What is the ratio of the Natural gas rent(as % of GDP) of 1970 in OECD members to that in World?
Give a very brief answer. 1.13. What is the ratio of the Natural gas rent(as % of GDP) of 1971 in OECD members to that in World?
Provide a succinct answer. 1.12. What is the ratio of the Natural gas rent(as % of GDP) in 1972 in OECD members to that in World?
Offer a terse response. 1.1. What is the ratio of the Natural gas rent(as % of GDP) of 1973 in OECD members to that in World?
Give a very brief answer. 1.1. What is the ratio of the Natural gas rent(as % of GDP) in 1970 in South Asia to that in Sub-Saharan Africa (all income levels)?
Ensure brevity in your answer.  28.57. What is the ratio of the Natural gas rent(as % of GDP) of 1971 in South Asia to that in Sub-Saharan Africa (all income levels)?
Ensure brevity in your answer.  9.07. What is the ratio of the Natural gas rent(as % of GDP) in 1972 in South Asia to that in Sub-Saharan Africa (all income levels)?
Provide a succinct answer. 7.67. What is the ratio of the Natural gas rent(as % of GDP) in 1973 in South Asia to that in Sub-Saharan Africa (all income levels)?
Provide a succinct answer. 4.13. What is the ratio of the Natural gas rent(as % of GDP) of 1970 in South Asia to that in Sub-Saharan Africa (developing only)?
Provide a succinct answer. 28.53. What is the ratio of the Natural gas rent(as % of GDP) in 1971 in South Asia to that in Sub-Saharan Africa (developing only)?
Your answer should be very brief. 9.06. What is the ratio of the Natural gas rent(as % of GDP) in 1972 in South Asia to that in Sub-Saharan Africa (developing only)?
Provide a succinct answer. 7.66. What is the ratio of the Natural gas rent(as % of GDP) of 1973 in South Asia to that in Sub-Saharan Africa (developing only)?
Give a very brief answer. 4.12. What is the ratio of the Natural gas rent(as % of GDP) of 1970 in South Asia to that in Upper middle income?
Give a very brief answer. 0.59. What is the ratio of the Natural gas rent(as % of GDP) of 1971 in South Asia to that in Upper middle income?
Keep it short and to the point. 0.47. What is the ratio of the Natural gas rent(as % of GDP) in 1972 in South Asia to that in Upper middle income?
Keep it short and to the point. 0.43. What is the ratio of the Natural gas rent(as % of GDP) in 1973 in South Asia to that in Upper middle income?
Give a very brief answer. 0.48. What is the ratio of the Natural gas rent(as % of GDP) of 1970 in South Asia to that in World?
Offer a very short reply. 0.2. What is the ratio of the Natural gas rent(as % of GDP) of 1971 in South Asia to that in World?
Offer a terse response. 0.19. What is the ratio of the Natural gas rent(as % of GDP) in 1972 in South Asia to that in World?
Your answer should be very brief. 0.2. What is the ratio of the Natural gas rent(as % of GDP) of 1973 in South Asia to that in World?
Your answer should be compact. 0.23. What is the ratio of the Natural gas rent(as % of GDP) of 1971 in Sub-Saharan Africa (all income levels) to that in Sub-Saharan Africa (developing only)?
Your answer should be very brief. 1. What is the ratio of the Natural gas rent(as % of GDP) of 1973 in Sub-Saharan Africa (all income levels) to that in Sub-Saharan Africa (developing only)?
Give a very brief answer. 1. What is the ratio of the Natural gas rent(as % of GDP) in 1970 in Sub-Saharan Africa (all income levels) to that in Upper middle income?
Keep it short and to the point. 0.02. What is the ratio of the Natural gas rent(as % of GDP) in 1971 in Sub-Saharan Africa (all income levels) to that in Upper middle income?
Provide a succinct answer. 0.05. What is the ratio of the Natural gas rent(as % of GDP) of 1972 in Sub-Saharan Africa (all income levels) to that in Upper middle income?
Ensure brevity in your answer.  0.06. What is the ratio of the Natural gas rent(as % of GDP) of 1973 in Sub-Saharan Africa (all income levels) to that in Upper middle income?
Provide a succinct answer. 0.12. What is the ratio of the Natural gas rent(as % of GDP) of 1970 in Sub-Saharan Africa (all income levels) to that in World?
Offer a very short reply. 0.01. What is the ratio of the Natural gas rent(as % of GDP) in 1971 in Sub-Saharan Africa (all income levels) to that in World?
Provide a short and direct response. 0.02. What is the ratio of the Natural gas rent(as % of GDP) in 1972 in Sub-Saharan Africa (all income levels) to that in World?
Your answer should be very brief. 0.03. What is the ratio of the Natural gas rent(as % of GDP) of 1973 in Sub-Saharan Africa (all income levels) to that in World?
Your response must be concise. 0.06. What is the ratio of the Natural gas rent(as % of GDP) of 1970 in Sub-Saharan Africa (developing only) to that in Upper middle income?
Ensure brevity in your answer.  0.02. What is the ratio of the Natural gas rent(as % of GDP) in 1971 in Sub-Saharan Africa (developing only) to that in Upper middle income?
Offer a terse response. 0.05. What is the ratio of the Natural gas rent(as % of GDP) of 1972 in Sub-Saharan Africa (developing only) to that in Upper middle income?
Keep it short and to the point. 0.06. What is the ratio of the Natural gas rent(as % of GDP) of 1973 in Sub-Saharan Africa (developing only) to that in Upper middle income?
Offer a terse response. 0.12. What is the ratio of the Natural gas rent(as % of GDP) of 1970 in Sub-Saharan Africa (developing only) to that in World?
Ensure brevity in your answer.  0.01. What is the ratio of the Natural gas rent(as % of GDP) of 1971 in Sub-Saharan Africa (developing only) to that in World?
Keep it short and to the point. 0.02. What is the ratio of the Natural gas rent(as % of GDP) of 1972 in Sub-Saharan Africa (developing only) to that in World?
Ensure brevity in your answer.  0.03. What is the ratio of the Natural gas rent(as % of GDP) of 1973 in Sub-Saharan Africa (developing only) to that in World?
Ensure brevity in your answer.  0.06. What is the ratio of the Natural gas rent(as % of GDP) of 1970 in Upper middle income to that in World?
Provide a succinct answer. 0.34. What is the ratio of the Natural gas rent(as % of GDP) of 1971 in Upper middle income to that in World?
Your answer should be very brief. 0.41. What is the ratio of the Natural gas rent(as % of GDP) in 1972 in Upper middle income to that in World?
Ensure brevity in your answer.  0.47. What is the ratio of the Natural gas rent(as % of GDP) in 1973 in Upper middle income to that in World?
Ensure brevity in your answer.  0.49. What is the difference between the highest and the second highest Natural gas rent(as % of GDP) in 1970?
Your answer should be very brief. 0.03. What is the difference between the highest and the second highest Natural gas rent(as % of GDP) of 1971?
Give a very brief answer. 0.03. What is the difference between the highest and the second highest Natural gas rent(as % of GDP) in 1972?
Your response must be concise. 0.03. What is the difference between the highest and the second highest Natural gas rent(as % of GDP) in 1973?
Make the answer very short. 0.03. What is the difference between the highest and the lowest Natural gas rent(as % of GDP) of 1970?
Make the answer very short. 0.29. What is the difference between the highest and the lowest Natural gas rent(as % of GDP) of 1971?
Make the answer very short. 0.32. What is the difference between the highest and the lowest Natural gas rent(as % of GDP) of 1972?
Your response must be concise. 0.29. What is the difference between the highest and the lowest Natural gas rent(as % of GDP) of 1973?
Offer a very short reply. 0.31. 